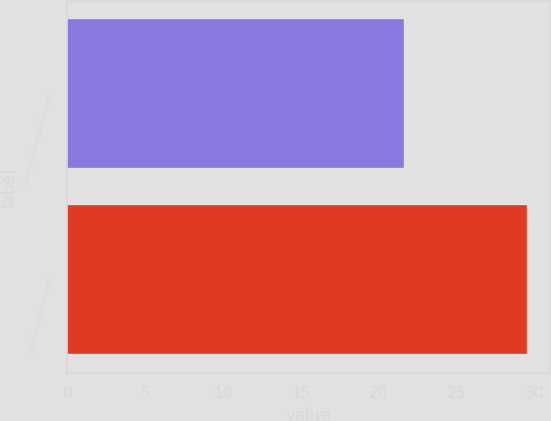<chart> <loc_0><loc_0><loc_500><loc_500><bar_chart><fcel>Foreign exchange contracts<fcel>Interest rate contracts<nl><fcel>21.6<fcel>29.5<nl></chart> 